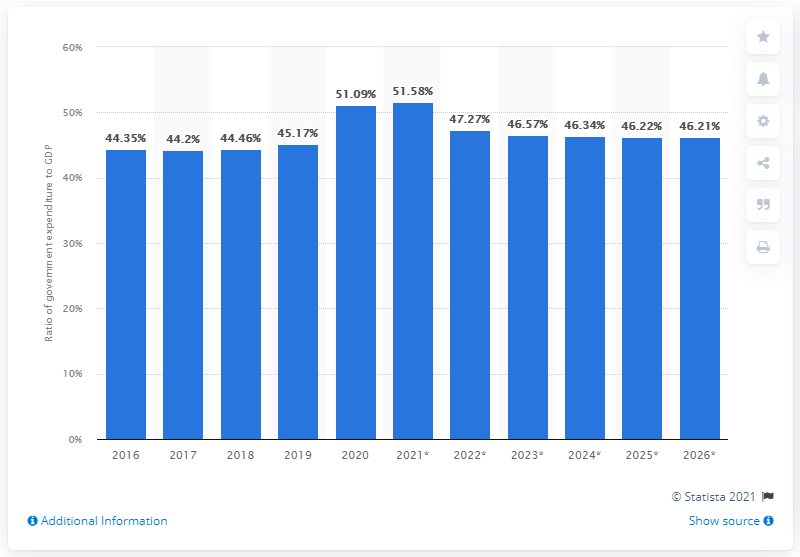Identify some key points in this picture. In 2020, government expenditure in Germany represented 49.8% of the country's Gross Domestic Product (GDP). 